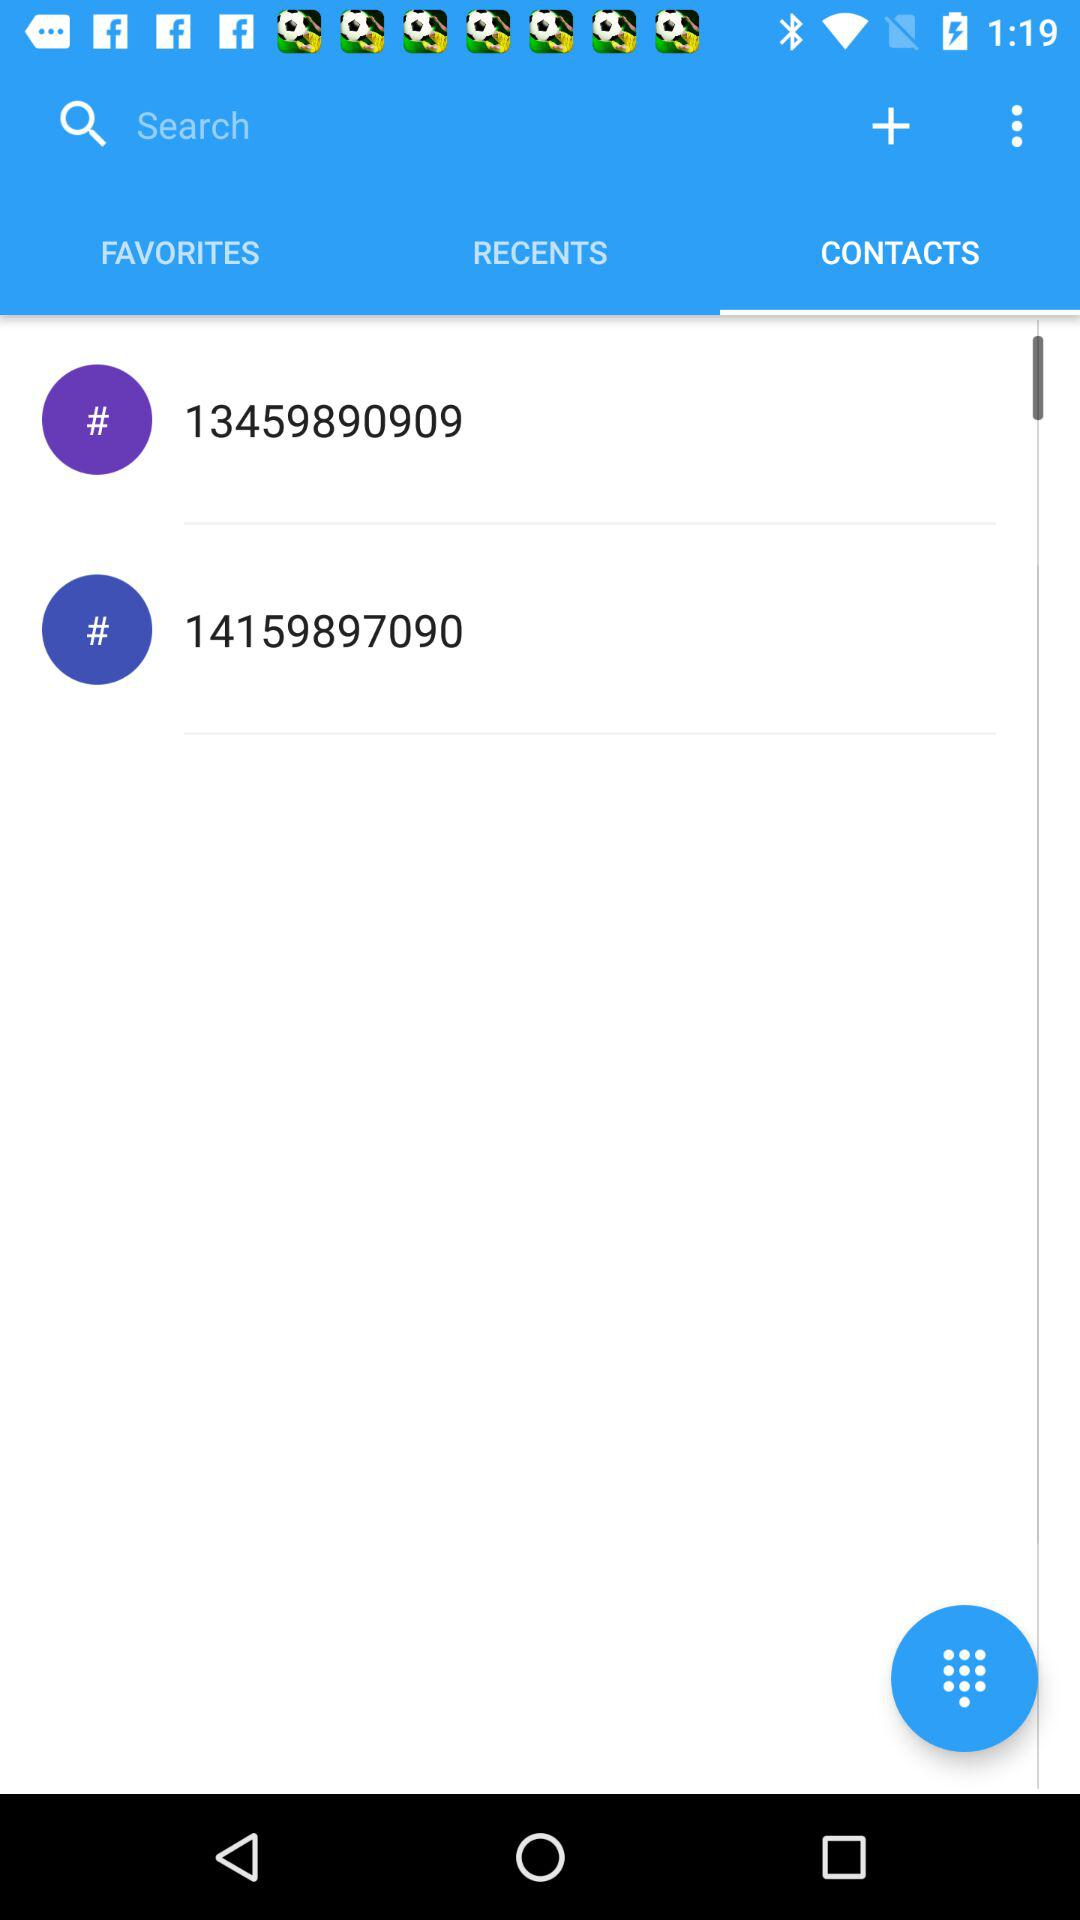Which tab has been selected? The selected tab is "CONTACTS". 